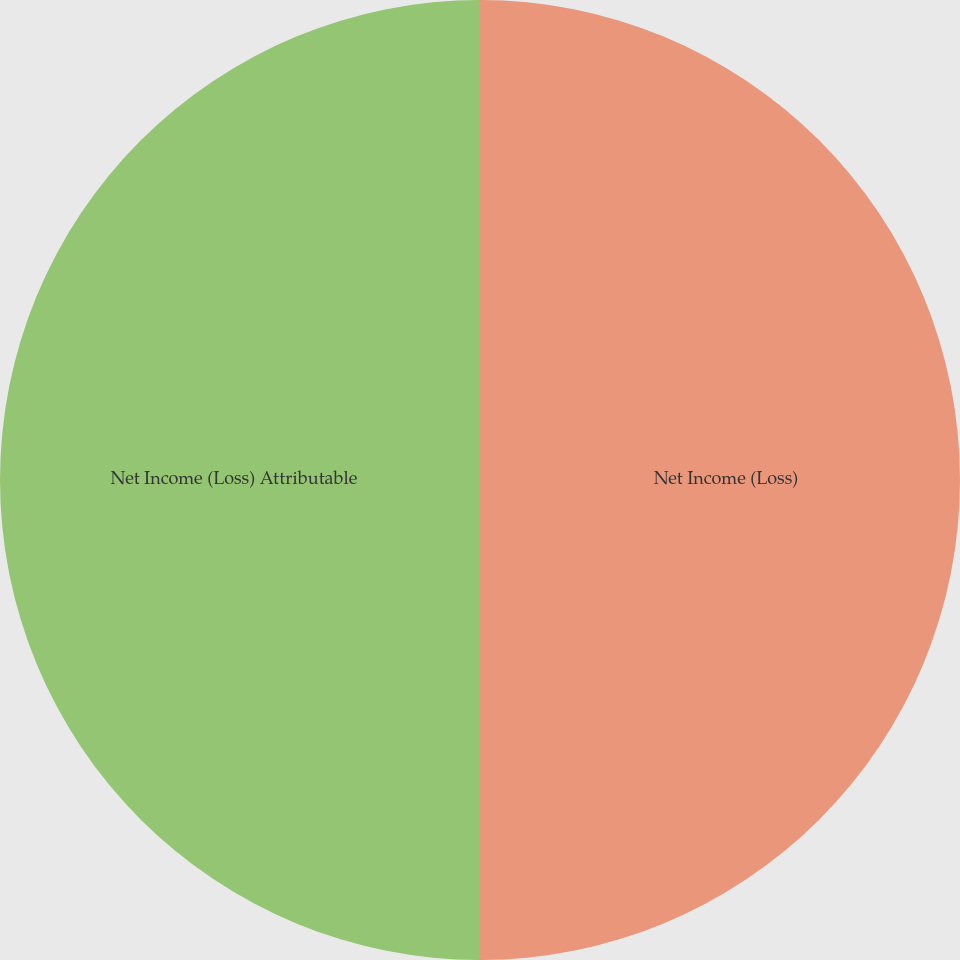Convert chart to OTSL. <chart><loc_0><loc_0><loc_500><loc_500><pie_chart><fcel>Net Income (Loss)<fcel>Net Income (Loss) Attributable<nl><fcel>50.0%<fcel>50.0%<nl></chart> 